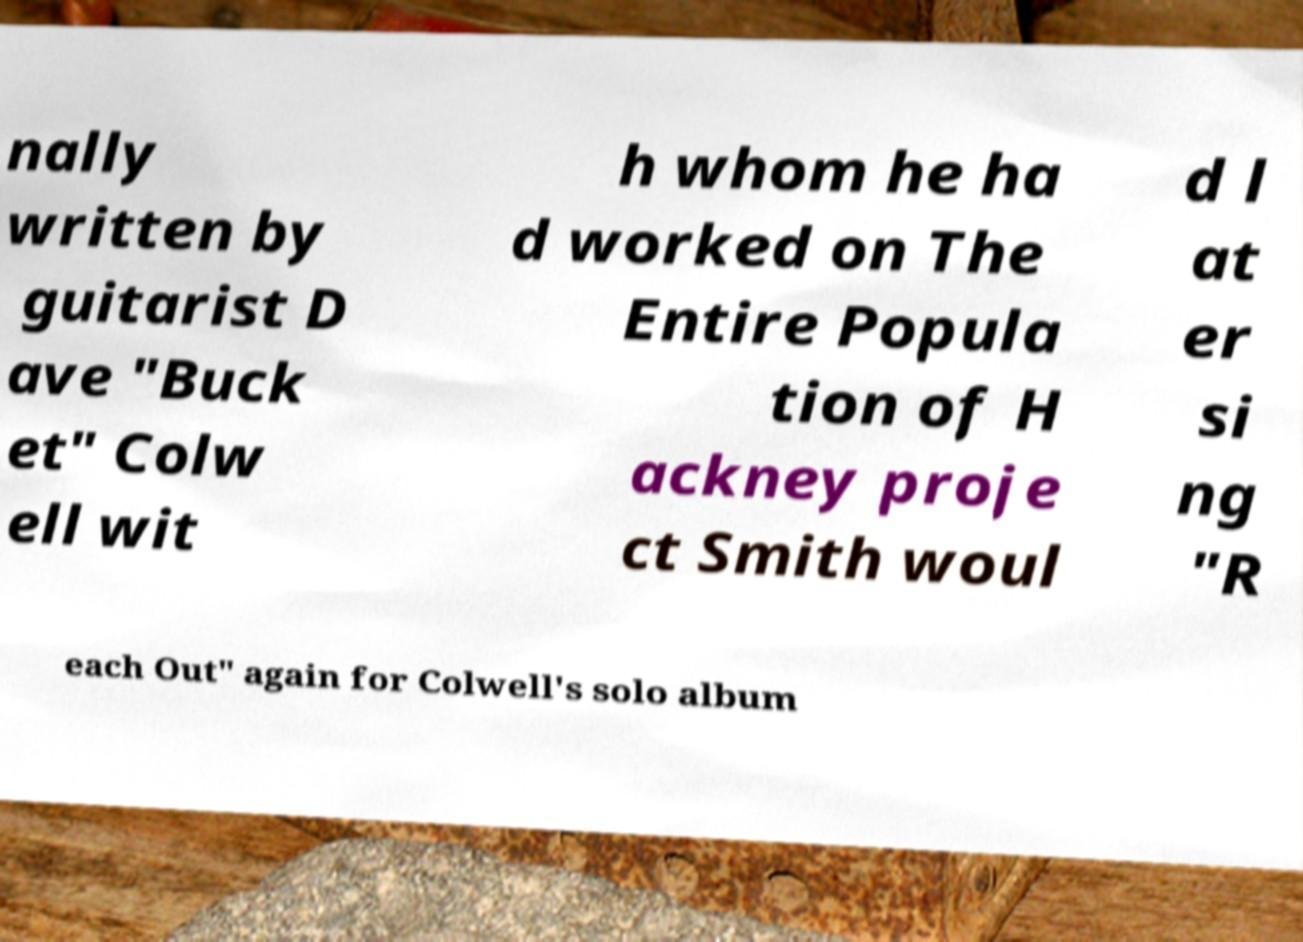Can you accurately transcribe the text from the provided image for me? nally written by guitarist D ave "Buck et" Colw ell wit h whom he ha d worked on The Entire Popula tion of H ackney proje ct Smith woul d l at er si ng "R each Out" again for Colwell's solo album 